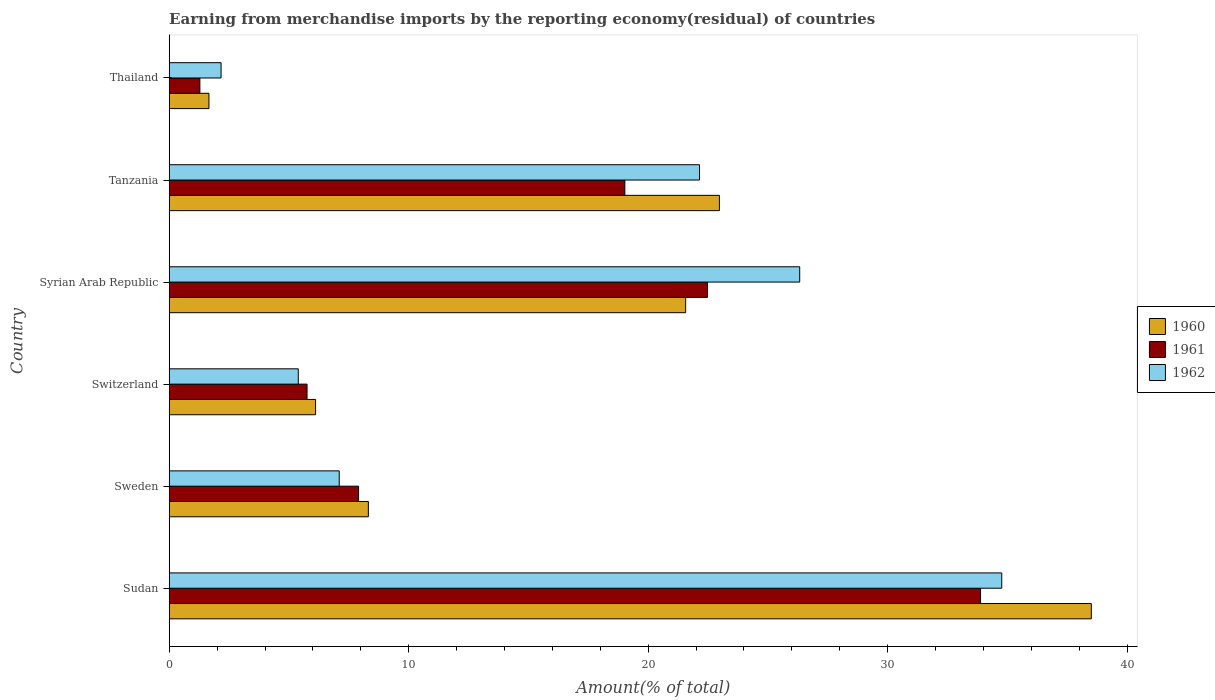Are the number of bars per tick equal to the number of legend labels?
Your answer should be very brief. Yes. How many bars are there on the 1st tick from the top?
Keep it short and to the point. 3. How many bars are there on the 2nd tick from the bottom?
Keep it short and to the point. 3. What is the label of the 3rd group of bars from the top?
Offer a very short reply. Syrian Arab Republic. What is the percentage of amount earned from merchandise imports in 1960 in Switzerland?
Offer a terse response. 6.11. Across all countries, what is the maximum percentage of amount earned from merchandise imports in 1962?
Ensure brevity in your answer.  34.76. Across all countries, what is the minimum percentage of amount earned from merchandise imports in 1960?
Ensure brevity in your answer.  1.66. In which country was the percentage of amount earned from merchandise imports in 1962 maximum?
Ensure brevity in your answer.  Sudan. In which country was the percentage of amount earned from merchandise imports in 1961 minimum?
Keep it short and to the point. Thailand. What is the total percentage of amount earned from merchandise imports in 1960 in the graph?
Provide a succinct answer. 99.13. What is the difference between the percentage of amount earned from merchandise imports in 1960 in Sweden and that in Syrian Arab Republic?
Your answer should be compact. -13.25. What is the difference between the percentage of amount earned from merchandise imports in 1962 in Switzerland and the percentage of amount earned from merchandise imports in 1961 in Syrian Arab Republic?
Your response must be concise. -17.09. What is the average percentage of amount earned from merchandise imports in 1962 per country?
Provide a succinct answer. 16.31. What is the difference between the percentage of amount earned from merchandise imports in 1962 and percentage of amount earned from merchandise imports in 1961 in Sweden?
Provide a succinct answer. -0.81. What is the ratio of the percentage of amount earned from merchandise imports in 1962 in Tanzania to that in Thailand?
Ensure brevity in your answer.  10.22. Is the difference between the percentage of amount earned from merchandise imports in 1962 in Sudan and Syrian Arab Republic greater than the difference between the percentage of amount earned from merchandise imports in 1961 in Sudan and Syrian Arab Republic?
Give a very brief answer. No. What is the difference between the highest and the second highest percentage of amount earned from merchandise imports in 1962?
Give a very brief answer. 8.44. What is the difference between the highest and the lowest percentage of amount earned from merchandise imports in 1961?
Give a very brief answer. 32.6. Is the sum of the percentage of amount earned from merchandise imports in 1962 in Sweden and Thailand greater than the maximum percentage of amount earned from merchandise imports in 1960 across all countries?
Ensure brevity in your answer.  No. What does the 1st bar from the bottom in Sudan represents?
Your answer should be compact. 1960. Is it the case that in every country, the sum of the percentage of amount earned from merchandise imports in 1960 and percentage of amount earned from merchandise imports in 1961 is greater than the percentage of amount earned from merchandise imports in 1962?
Keep it short and to the point. Yes. How many bars are there?
Provide a succinct answer. 18. What is the difference between two consecutive major ticks on the X-axis?
Your answer should be very brief. 10. Are the values on the major ticks of X-axis written in scientific E-notation?
Your response must be concise. No. Does the graph contain grids?
Keep it short and to the point. No. How are the legend labels stacked?
Keep it short and to the point. Vertical. What is the title of the graph?
Offer a very short reply. Earning from merchandise imports by the reporting economy(residual) of countries. What is the label or title of the X-axis?
Your answer should be very brief. Amount(% of total). What is the Amount(% of total) in 1960 in Sudan?
Your response must be concise. 38.5. What is the Amount(% of total) in 1961 in Sudan?
Give a very brief answer. 33.88. What is the Amount(% of total) in 1962 in Sudan?
Provide a succinct answer. 34.76. What is the Amount(% of total) of 1960 in Sweden?
Your answer should be very brief. 8.32. What is the Amount(% of total) in 1961 in Sweden?
Your answer should be very brief. 7.91. What is the Amount(% of total) in 1962 in Sweden?
Provide a succinct answer. 7.1. What is the Amount(% of total) in 1960 in Switzerland?
Make the answer very short. 6.11. What is the Amount(% of total) in 1961 in Switzerland?
Offer a very short reply. 5.76. What is the Amount(% of total) in 1962 in Switzerland?
Your answer should be compact. 5.39. What is the Amount(% of total) of 1960 in Syrian Arab Republic?
Provide a short and direct response. 21.56. What is the Amount(% of total) of 1961 in Syrian Arab Republic?
Your response must be concise. 22.48. What is the Amount(% of total) of 1962 in Syrian Arab Republic?
Give a very brief answer. 26.33. What is the Amount(% of total) of 1960 in Tanzania?
Ensure brevity in your answer.  22.97. What is the Amount(% of total) in 1961 in Tanzania?
Offer a terse response. 19.03. What is the Amount(% of total) of 1962 in Tanzania?
Your response must be concise. 22.14. What is the Amount(% of total) of 1960 in Thailand?
Your answer should be compact. 1.66. What is the Amount(% of total) of 1961 in Thailand?
Ensure brevity in your answer.  1.28. What is the Amount(% of total) in 1962 in Thailand?
Offer a terse response. 2.17. Across all countries, what is the maximum Amount(% of total) in 1960?
Your answer should be compact. 38.5. Across all countries, what is the maximum Amount(% of total) of 1961?
Provide a short and direct response. 33.88. Across all countries, what is the maximum Amount(% of total) in 1962?
Your answer should be very brief. 34.76. Across all countries, what is the minimum Amount(% of total) of 1960?
Provide a succinct answer. 1.66. Across all countries, what is the minimum Amount(% of total) of 1961?
Your answer should be compact. 1.28. Across all countries, what is the minimum Amount(% of total) in 1962?
Provide a short and direct response. 2.17. What is the total Amount(% of total) of 1960 in the graph?
Ensure brevity in your answer.  99.13. What is the total Amount(% of total) in 1961 in the graph?
Your response must be concise. 90.32. What is the total Amount(% of total) in 1962 in the graph?
Your answer should be very brief. 97.89. What is the difference between the Amount(% of total) of 1960 in Sudan and that in Sweden?
Your answer should be very brief. 30.19. What is the difference between the Amount(% of total) of 1961 in Sudan and that in Sweden?
Provide a succinct answer. 25.97. What is the difference between the Amount(% of total) of 1962 in Sudan and that in Sweden?
Make the answer very short. 27.66. What is the difference between the Amount(% of total) of 1960 in Sudan and that in Switzerland?
Ensure brevity in your answer.  32.39. What is the difference between the Amount(% of total) in 1961 in Sudan and that in Switzerland?
Your answer should be compact. 28.12. What is the difference between the Amount(% of total) in 1962 in Sudan and that in Switzerland?
Your answer should be compact. 29.37. What is the difference between the Amount(% of total) of 1960 in Sudan and that in Syrian Arab Republic?
Your answer should be very brief. 16.94. What is the difference between the Amount(% of total) in 1961 in Sudan and that in Syrian Arab Republic?
Provide a succinct answer. 11.4. What is the difference between the Amount(% of total) of 1962 in Sudan and that in Syrian Arab Republic?
Keep it short and to the point. 8.44. What is the difference between the Amount(% of total) of 1960 in Sudan and that in Tanzania?
Give a very brief answer. 15.53. What is the difference between the Amount(% of total) of 1961 in Sudan and that in Tanzania?
Ensure brevity in your answer.  14.85. What is the difference between the Amount(% of total) in 1962 in Sudan and that in Tanzania?
Provide a short and direct response. 12.62. What is the difference between the Amount(% of total) of 1960 in Sudan and that in Thailand?
Your response must be concise. 36.85. What is the difference between the Amount(% of total) in 1961 in Sudan and that in Thailand?
Your response must be concise. 32.6. What is the difference between the Amount(% of total) in 1962 in Sudan and that in Thailand?
Keep it short and to the point. 32.6. What is the difference between the Amount(% of total) of 1960 in Sweden and that in Switzerland?
Give a very brief answer. 2.2. What is the difference between the Amount(% of total) in 1961 in Sweden and that in Switzerland?
Offer a very short reply. 2.15. What is the difference between the Amount(% of total) of 1962 in Sweden and that in Switzerland?
Your answer should be compact. 1.71. What is the difference between the Amount(% of total) in 1960 in Sweden and that in Syrian Arab Republic?
Provide a short and direct response. -13.25. What is the difference between the Amount(% of total) of 1961 in Sweden and that in Syrian Arab Republic?
Provide a short and direct response. -14.57. What is the difference between the Amount(% of total) of 1962 in Sweden and that in Syrian Arab Republic?
Offer a terse response. -19.23. What is the difference between the Amount(% of total) of 1960 in Sweden and that in Tanzania?
Your answer should be very brief. -14.66. What is the difference between the Amount(% of total) of 1961 in Sweden and that in Tanzania?
Give a very brief answer. -11.12. What is the difference between the Amount(% of total) in 1962 in Sweden and that in Tanzania?
Provide a short and direct response. -15.04. What is the difference between the Amount(% of total) in 1960 in Sweden and that in Thailand?
Give a very brief answer. 6.66. What is the difference between the Amount(% of total) in 1961 in Sweden and that in Thailand?
Offer a terse response. 6.63. What is the difference between the Amount(% of total) of 1962 in Sweden and that in Thailand?
Offer a terse response. 4.93. What is the difference between the Amount(% of total) in 1960 in Switzerland and that in Syrian Arab Republic?
Your answer should be very brief. -15.45. What is the difference between the Amount(% of total) of 1961 in Switzerland and that in Syrian Arab Republic?
Your answer should be compact. -16.72. What is the difference between the Amount(% of total) in 1962 in Switzerland and that in Syrian Arab Republic?
Your answer should be compact. -20.94. What is the difference between the Amount(% of total) in 1960 in Switzerland and that in Tanzania?
Ensure brevity in your answer.  -16.86. What is the difference between the Amount(% of total) in 1961 in Switzerland and that in Tanzania?
Keep it short and to the point. -13.27. What is the difference between the Amount(% of total) of 1962 in Switzerland and that in Tanzania?
Make the answer very short. -16.75. What is the difference between the Amount(% of total) of 1960 in Switzerland and that in Thailand?
Make the answer very short. 4.45. What is the difference between the Amount(% of total) in 1961 in Switzerland and that in Thailand?
Offer a terse response. 4.47. What is the difference between the Amount(% of total) of 1962 in Switzerland and that in Thailand?
Your answer should be compact. 3.22. What is the difference between the Amount(% of total) in 1960 in Syrian Arab Republic and that in Tanzania?
Your answer should be compact. -1.41. What is the difference between the Amount(% of total) of 1961 in Syrian Arab Republic and that in Tanzania?
Your answer should be compact. 3.45. What is the difference between the Amount(% of total) in 1962 in Syrian Arab Republic and that in Tanzania?
Provide a succinct answer. 4.18. What is the difference between the Amount(% of total) of 1960 in Syrian Arab Republic and that in Thailand?
Your answer should be very brief. 19.91. What is the difference between the Amount(% of total) in 1961 in Syrian Arab Republic and that in Thailand?
Provide a short and direct response. 21.19. What is the difference between the Amount(% of total) in 1962 in Syrian Arab Republic and that in Thailand?
Offer a very short reply. 24.16. What is the difference between the Amount(% of total) in 1960 in Tanzania and that in Thailand?
Ensure brevity in your answer.  21.32. What is the difference between the Amount(% of total) in 1961 in Tanzania and that in Thailand?
Keep it short and to the point. 17.74. What is the difference between the Amount(% of total) in 1962 in Tanzania and that in Thailand?
Your answer should be very brief. 19.98. What is the difference between the Amount(% of total) of 1960 in Sudan and the Amount(% of total) of 1961 in Sweden?
Give a very brief answer. 30.6. What is the difference between the Amount(% of total) of 1960 in Sudan and the Amount(% of total) of 1962 in Sweden?
Provide a succinct answer. 31.4. What is the difference between the Amount(% of total) of 1961 in Sudan and the Amount(% of total) of 1962 in Sweden?
Provide a succinct answer. 26.78. What is the difference between the Amount(% of total) in 1960 in Sudan and the Amount(% of total) in 1961 in Switzerland?
Provide a succinct answer. 32.75. What is the difference between the Amount(% of total) in 1960 in Sudan and the Amount(% of total) in 1962 in Switzerland?
Give a very brief answer. 33.11. What is the difference between the Amount(% of total) in 1961 in Sudan and the Amount(% of total) in 1962 in Switzerland?
Your response must be concise. 28.49. What is the difference between the Amount(% of total) in 1960 in Sudan and the Amount(% of total) in 1961 in Syrian Arab Republic?
Ensure brevity in your answer.  16.03. What is the difference between the Amount(% of total) of 1960 in Sudan and the Amount(% of total) of 1962 in Syrian Arab Republic?
Provide a succinct answer. 12.18. What is the difference between the Amount(% of total) in 1961 in Sudan and the Amount(% of total) in 1962 in Syrian Arab Republic?
Provide a short and direct response. 7.55. What is the difference between the Amount(% of total) in 1960 in Sudan and the Amount(% of total) in 1961 in Tanzania?
Your answer should be very brief. 19.48. What is the difference between the Amount(% of total) of 1960 in Sudan and the Amount(% of total) of 1962 in Tanzania?
Provide a short and direct response. 16.36. What is the difference between the Amount(% of total) of 1961 in Sudan and the Amount(% of total) of 1962 in Tanzania?
Ensure brevity in your answer.  11.74. What is the difference between the Amount(% of total) in 1960 in Sudan and the Amount(% of total) in 1961 in Thailand?
Keep it short and to the point. 37.22. What is the difference between the Amount(% of total) of 1960 in Sudan and the Amount(% of total) of 1962 in Thailand?
Provide a short and direct response. 36.34. What is the difference between the Amount(% of total) in 1961 in Sudan and the Amount(% of total) in 1962 in Thailand?
Your answer should be very brief. 31.71. What is the difference between the Amount(% of total) in 1960 in Sweden and the Amount(% of total) in 1961 in Switzerland?
Keep it short and to the point. 2.56. What is the difference between the Amount(% of total) of 1960 in Sweden and the Amount(% of total) of 1962 in Switzerland?
Your answer should be compact. 2.93. What is the difference between the Amount(% of total) in 1961 in Sweden and the Amount(% of total) in 1962 in Switzerland?
Provide a short and direct response. 2.52. What is the difference between the Amount(% of total) of 1960 in Sweden and the Amount(% of total) of 1961 in Syrian Arab Republic?
Provide a short and direct response. -14.16. What is the difference between the Amount(% of total) in 1960 in Sweden and the Amount(% of total) in 1962 in Syrian Arab Republic?
Keep it short and to the point. -18.01. What is the difference between the Amount(% of total) of 1961 in Sweden and the Amount(% of total) of 1962 in Syrian Arab Republic?
Keep it short and to the point. -18.42. What is the difference between the Amount(% of total) in 1960 in Sweden and the Amount(% of total) in 1961 in Tanzania?
Your answer should be very brief. -10.71. What is the difference between the Amount(% of total) in 1960 in Sweden and the Amount(% of total) in 1962 in Tanzania?
Provide a succinct answer. -13.83. What is the difference between the Amount(% of total) in 1961 in Sweden and the Amount(% of total) in 1962 in Tanzania?
Your response must be concise. -14.24. What is the difference between the Amount(% of total) of 1960 in Sweden and the Amount(% of total) of 1961 in Thailand?
Your answer should be compact. 7.04. What is the difference between the Amount(% of total) of 1960 in Sweden and the Amount(% of total) of 1962 in Thailand?
Give a very brief answer. 6.15. What is the difference between the Amount(% of total) of 1961 in Sweden and the Amount(% of total) of 1962 in Thailand?
Give a very brief answer. 5.74. What is the difference between the Amount(% of total) in 1960 in Switzerland and the Amount(% of total) in 1961 in Syrian Arab Republic?
Keep it short and to the point. -16.36. What is the difference between the Amount(% of total) in 1960 in Switzerland and the Amount(% of total) in 1962 in Syrian Arab Republic?
Offer a terse response. -20.21. What is the difference between the Amount(% of total) in 1961 in Switzerland and the Amount(% of total) in 1962 in Syrian Arab Republic?
Provide a short and direct response. -20.57. What is the difference between the Amount(% of total) of 1960 in Switzerland and the Amount(% of total) of 1961 in Tanzania?
Your answer should be very brief. -12.91. What is the difference between the Amount(% of total) of 1960 in Switzerland and the Amount(% of total) of 1962 in Tanzania?
Your answer should be compact. -16.03. What is the difference between the Amount(% of total) of 1961 in Switzerland and the Amount(% of total) of 1962 in Tanzania?
Provide a succinct answer. -16.39. What is the difference between the Amount(% of total) in 1960 in Switzerland and the Amount(% of total) in 1961 in Thailand?
Your answer should be very brief. 4.83. What is the difference between the Amount(% of total) of 1960 in Switzerland and the Amount(% of total) of 1962 in Thailand?
Ensure brevity in your answer.  3.95. What is the difference between the Amount(% of total) in 1961 in Switzerland and the Amount(% of total) in 1962 in Thailand?
Your answer should be very brief. 3.59. What is the difference between the Amount(% of total) of 1960 in Syrian Arab Republic and the Amount(% of total) of 1961 in Tanzania?
Your response must be concise. 2.54. What is the difference between the Amount(% of total) in 1960 in Syrian Arab Republic and the Amount(% of total) in 1962 in Tanzania?
Give a very brief answer. -0.58. What is the difference between the Amount(% of total) of 1961 in Syrian Arab Republic and the Amount(% of total) of 1962 in Tanzania?
Offer a very short reply. 0.33. What is the difference between the Amount(% of total) of 1960 in Syrian Arab Republic and the Amount(% of total) of 1961 in Thailand?
Offer a terse response. 20.28. What is the difference between the Amount(% of total) in 1960 in Syrian Arab Republic and the Amount(% of total) in 1962 in Thailand?
Keep it short and to the point. 19.4. What is the difference between the Amount(% of total) in 1961 in Syrian Arab Republic and the Amount(% of total) in 1962 in Thailand?
Offer a very short reply. 20.31. What is the difference between the Amount(% of total) in 1960 in Tanzania and the Amount(% of total) in 1961 in Thailand?
Offer a very short reply. 21.69. What is the difference between the Amount(% of total) of 1960 in Tanzania and the Amount(% of total) of 1962 in Thailand?
Offer a very short reply. 20.81. What is the difference between the Amount(% of total) in 1961 in Tanzania and the Amount(% of total) in 1962 in Thailand?
Offer a terse response. 16.86. What is the average Amount(% of total) of 1960 per country?
Provide a succinct answer. 16.52. What is the average Amount(% of total) in 1961 per country?
Make the answer very short. 15.05. What is the average Amount(% of total) in 1962 per country?
Offer a terse response. 16.31. What is the difference between the Amount(% of total) of 1960 and Amount(% of total) of 1961 in Sudan?
Your response must be concise. 4.63. What is the difference between the Amount(% of total) in 1960 and Amount(% of total) in 1962 in Sudan?
Ensure brevity in your answer.  3.74. What is the difference between the Amount(% of total) of 1961 and Amount(% of total) of 1962 in Sudan?
Keep it short and to the point. -0.89. What is the difference between the Amount(% of total) of 1960 and Amount(% of total) of 1961 in Sweden?
Your answer should be very brief. 0.41. What is the difference between the Amount(% of total) in 1960 and Amount(% of total) in 1962 in Sweden?
Ensure brevity in your answer.  1.22. What is the difference between the Amount(% of total) in 1961 and Amount(% of total) in 1962 in Sweden?
Ensure brevity in your answer.  0.81. What is the difference between the Amount(% of total) in 1960 and Amount(% of total) in 1961 in Switzerland?
Keep it short and to the point. 0.36. What is the difference between the Amount(% of total) in 1960 and Amount(% of total) in 1962 in Switzerland?
Make the answer very short. 0.72. What is the difference between the Amount(% of total) in 1961 and Amount(% of total) in 1962 in Switzerland?
Provide a short and direct response. 0.37. What is the difference between the Amount(% of total) in 1960 and Amount(% of total) in 1961 in Syrian Arab Republic?
Keep it short and to the point. -0.91. What is the difference between the Amount(% of total) of 1960 and Amount(% of total) of 1962 in Syrian Arab Republic?
Your answer should be compact. -4.76. What is the difference between the Amount(% of total) of 1961 and Amount(% of total) of 1962 in Syrian Arab Republic?
Your answer should be compact. -3.85. What is the difference between the Amount(% of total) in 1960 and Amount(% of total) in 1961 in Tanzania?
Your answer should be compact. 3.95. What is the difference between the Amount(% of total) in 1960 and Amount(% of total) in 1962 in Tanzania?
Ensure brevity in your answer.  0.83. What is the difference between the Amount(% of total) of 1961 and Amount(% of total) of 1962 in Tanzania?
Offer a terse response. -3.12. What is the difference between the Amount(% of total) in 1960 and Amount(% of total) in 1961 in Thailand?
Make the answer very short. 0.38. What is the difference between the Amount(% of total) in 1960 and Amount(% of total) in 1962 in Thailand?
Provide a short and direct response. -0.51. What is the difference between the Amount(% of total) of 1961 and Amount(% of total) of 1962 in Thailand?
Offer a very short reply. -0.89. What is the ratio of the Amount(% of total) of 1960 in Sudan to that in Sweden?
Provide a succinct answer. 4.63. What is the ratio of the Amount(% of total) of 1961 in Sudan to that in Sweden?
Provide a succinct answer. 4.28. What is the ratio of the Amount(% of total) of 1962 in Sudan to that in Sweden?
Provide a succinct answer. 4.9. What is the ratio of the Amount(% of total) in 1960 in Sudan to that in Switzerland?
Offer a terse response. 6.3. What is the ratio of the Amount(% of total) in 1961 in Sudan to that in Switzerland?
Make the answer very short. 5.89. What is the ratio of the Amount(% of total) in 1962 in Sudan to that in Switzerland?
Your answer should be very brief. 6.45. What is the ratio of the Amount(% of total) of 1960 in Sudan to that in Syrian Arab Republic?
Your answer should be very brief. 1.79. What is the ratio of the Amount(% of total) in 1961 in Sudan to that in Syrian Arab Republic?
Provide a succinct answer. 1.51. What is the ratio of the Amount(% of total) of 1962 in Sudan to that in Syrian Arab Republic?
Your answer should be compact. 1.32. What is the ratio of the Amount(% of total) of 1960 in Sudan to that in Tanzania?
Ensure brevity in your answer.  1.68. What is the ratio of the Amount(% of total) of 1961 in Sudan to that in Tanzania?
Offer a very short reply. 1.78. What is the ratio of the Amount(% of total) of 1962 in Sudan to that in Tanzania?
Provide a succinct answer. 1.57. What is the ratio of the Amount(% of total) of 1960 in Sudan to that in Thailand?
Your answer should be very brief. 23.21. What is the ratio of the Amount(% of total) in 1961 in Sudan to that in Thailand?
Your response must be concise. 26.45. What is the ratio of the Amount(% of total) in 1962 in Sudan to that in Thailand?
Ensure brevity in your answer.  16.05. What is the ratio of the Amount(% of total) in 1960 in Sweden to that in Switzerland?
Provide a succinct answer. 1.36. What is the ratio of the Amount(% of total) of 1961 in Sweden to that in Switzerland?
Give a very brief answer. 1.37. What is the ratio of the Amount(% of total) of 1962 in Sweden to that in Switzerland?
Provide a short and direct response. 1.32. What is the ratio of the Amount(% of total) of 1960 in Sweden to that in Syrian Arab Republic?
Provide a short and direct response. 0.39. What is the ratio of the Amount(% of total) in 1961 in Sweden to that in Syrian Arab Republic?
Make the answer very short. 0.35. What is the ratio of the Amount(% of total) in 1962 in Sweden to that in Syrian Arab Republic?
Your answer should be very brief. 0.27. What is the ratio of the Amount(% of total) in 1960 in Sweden to that in Tanzania?
Ensure brevity in your answer.  0.36. What is the ratio of the Amount(% of total) in 1961 in Sweden to that in Tanzania?
Your answer should be compact. 0.42. What is the ratio of the Amount(% of total) of 1962 in Sweden to that in Tanzania?
Provide a short and direct response. 0.32. What is the ratio of the Amount(% of total) in 1960 in Sweden to that in Thailand?
Give a very brief answer. 5.01. What is the ratio of the Amount(% of total) of 1961 in Sweden to that in Thailand?
Ensure brevity in your answer.  6.17. What is the ratio of the Amount(% of total) in 1962 in Sweden to that in Thailand?
Your response must be concise. 3.28. What is the ratio of the Amount(% of total) of 1960 in Switzerland to that in Syrian Arab Republic?
Give a very brief answer. 0.28. What is the ratio of the Amount(% of total) in 1961 in Switzerland to that in Syrian Arab Republic?
Offer a terse response. 0.26. What is the ratio of the Amount(% of total) in 1962 in Switzerland to that in Syrian Arab Republic?
Ensure brevity in your answer.  0.2. What is the ratio of the Amount(% of total) in 1960 in Switzerland to that in Tanzania?
Ensure brevity in your answer.  0.27. What is the ratio of the Amount(% of total) in 1961 in Switzerland to that in Tanzania?
Your response must be concise. 0.3. What is the ratio of the Amount(% of total) in 1962 in Switzerland to that in Tanzania?
Your answer should be very brief. 0.24. What is the ratio of the Amount(% of total) in 1960 in Switzerland to that in Thailand?
Ensure brevity in your answer.  3.68. What is the ratio of the Amount(% of total) of 1961 in Switzerland to that in Thailand?
Offer a terse response. 4.49. What is the ratio of the Amount(% of total) in 1962 in Switzerland to that in Thailand?
Provide a succinct answer. 2.49. What is the ratio of the Amount(% of total) in 1960 in Syrian Arab Republic to that in Tanzania?
Your answer should be compact. 0.94. What is the ratio of the Amount(% of total) in 1961 in Syrian Arab Republic to that in Tanzania?
Provide a succinct answer. 1.18. What is the ratio of the Amount(% of total) of 1962 in Syrian Arab Republic to that in Tanzania?
Ensure brevity in your answer.  1.19. What is the ratio of the Amount(% of total) in 1960 in Syrian Arab Republic to that in Thailand?
Ensure brevity in your answer.  13. What is the ratio of the Amount(% of total) in 1961 in Syrian Arab Republic to that in Thailand?
Ensure brevity in your answer.  17.55. What is the ratio of the Amount(% of total) of 1962 in Syrian Arab Republic to that in Thailand?
Ensure brevity in your answer.  12.15. What is the ratio of the Amount(% of total) in 1960 in Tanzania to that in Thailand?
Your answer should be compact. 13.85. What is the ratio of the Amount(% of total) in 1961 in Tanzania to that in Thailand?
Your answer should be compact. 14.85. What is the ratio of the Amount(% of total) in 1962 in Tanzania to that in Thailand?
Ensure brevity in your answer.  10.22. What is the difference between the highest and the second highest Amount(% of total) of 1960?
Your response must be concise. 15.53. What is the difference between the highest and the second highest Amount(% of total) of 1961?
Provide a short and direct response. 11.4. What is the difference between the highest and the second highest Amount(% of total) of 1962?
Ensure brevity in your answer.  8.44. What is the difference between the highest and the lowest Amount(% of total) in 1960?
Provide a short and direct response. 36.85. What is the difference between the highest and the lowest Amount(% of total) in 1961?
Keep it short and to the point. 32.6. What is the difference between the highest and the lowest Amount(% of total) of 1962?
Your response must be concise. 32.6. 